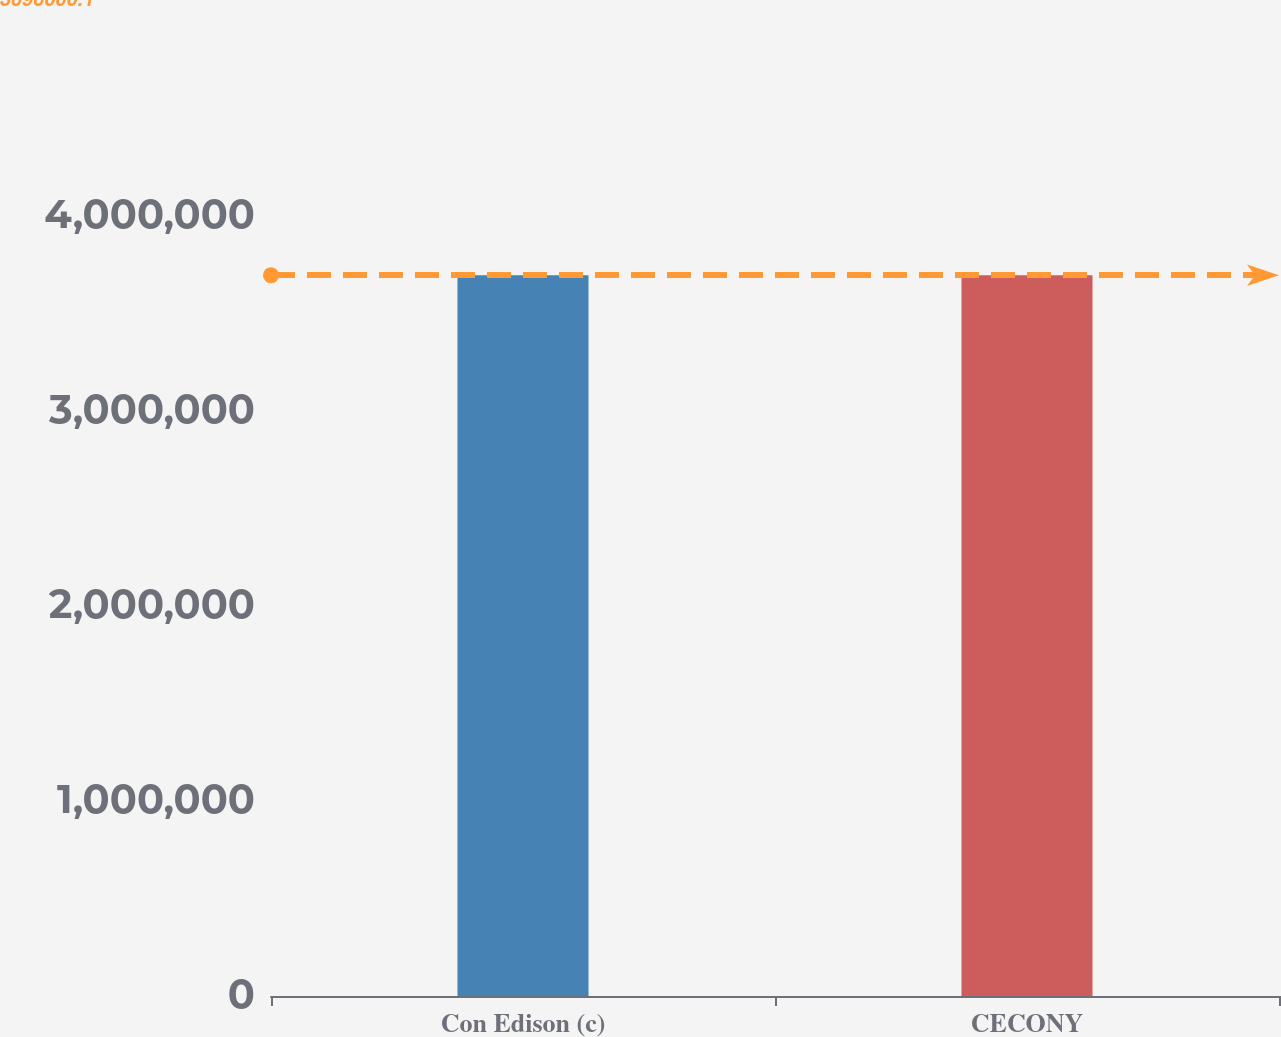Convert chart to OTSL. <chart><loc_0><loc_0><loc_500><loc_500><bar_chart><fcel>Con Edison (c)<fcel>CECONY<nl><fcel>3.696e+06<fcel>3.696e+06<nl></chart> 